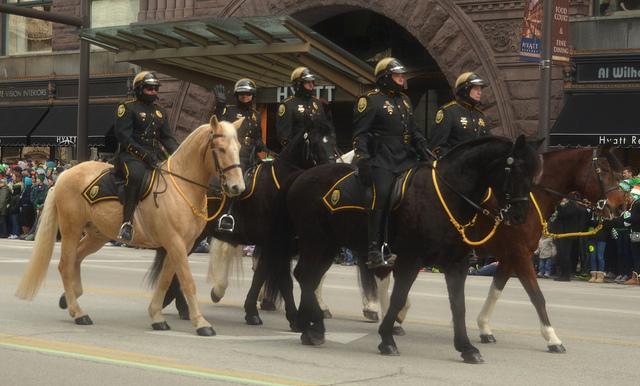What color is the writing on the horses?
Give a very brief answer. Yellow. How many horses are in the picture?
Write a very short answer. 4. How many riders are in the picture?
Give a very brief answer. 5. How many horses do you see?
Be succinct. 4. Are the horses all the same color?
Give a very brief answer. No. What type of people are riding the horses?
Write a very short answer. Police. 